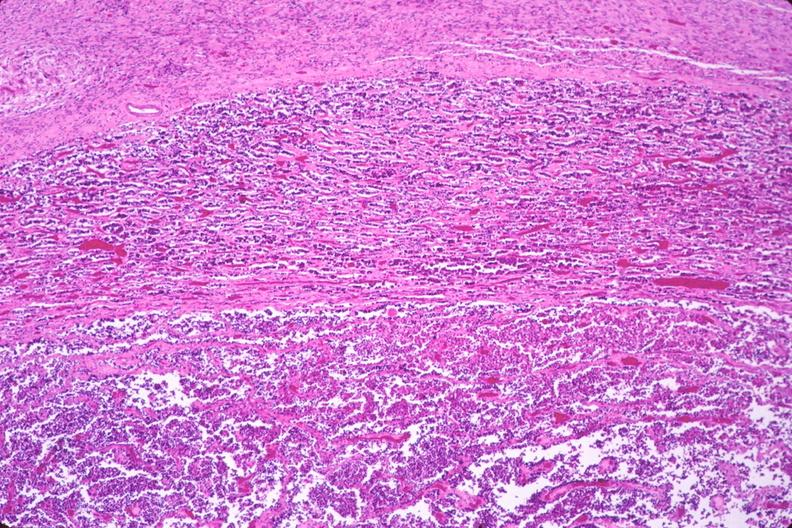s artery present?
Answer the question using a single word or phrase. No 